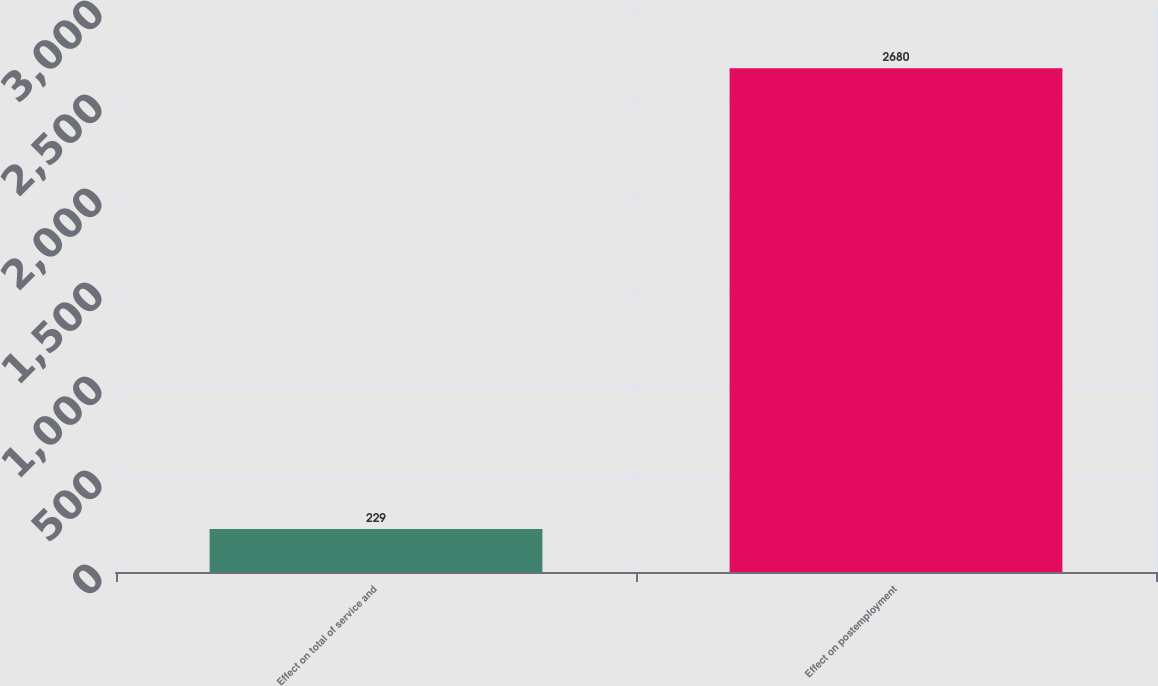<chart> <loc_0><loc_0><loc_500><loc_500><bar_chart><fcel>Effect on total of service and<fcel>Effect on postemployment<nl><fcel>229<fcel>2680<nl></chart> 